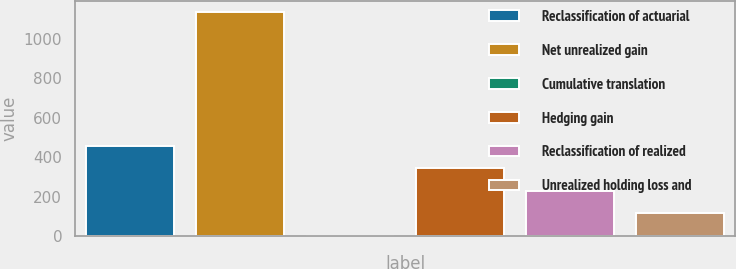Convert chart to OTSL. <chart><loc_0><loc_0><loc_500><loc_500><bar_chart><fcel>Reclassification of actuarial<fcel>Net unrealized gain<fcel>Cumulative translation<fcel>Hedging gain<fcel>Reclassification of realized<fcel>Unrealized holding loss and<nl><fcel>456.2<fcel>1136<fcel>3<fcel>342.9<fcel>229.6<fcel>116.3<nl></chart> 